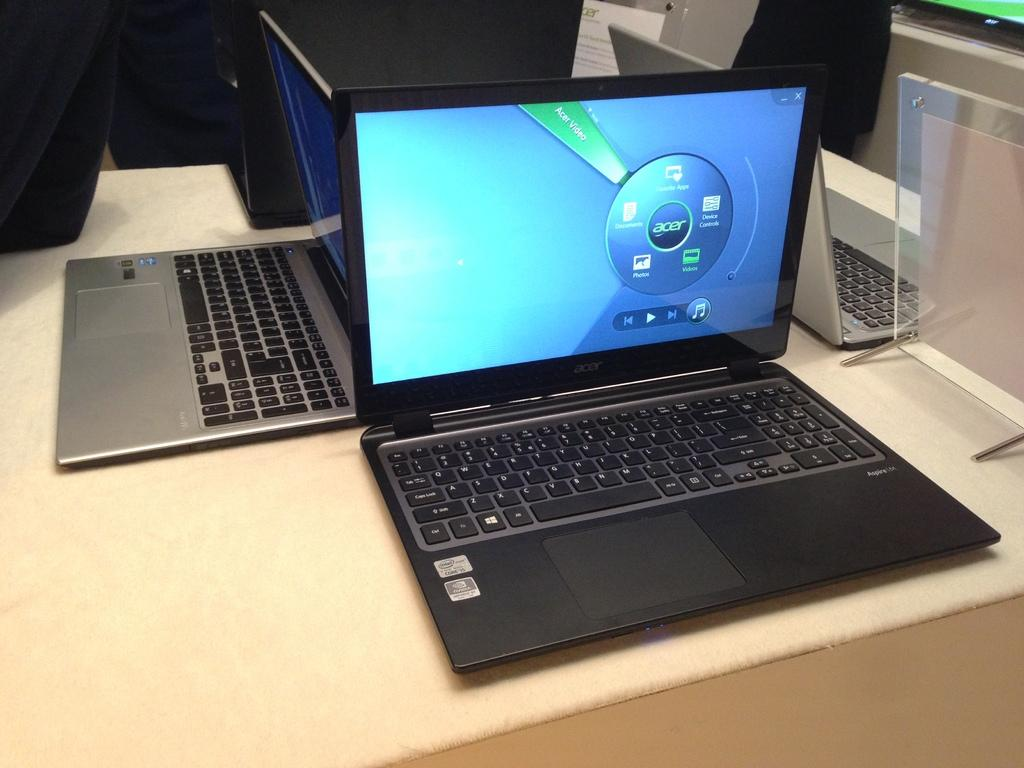<image>
Give a short and clear explanation of the subsequent image. A black Aspire laptop sits open next to other laptops. 